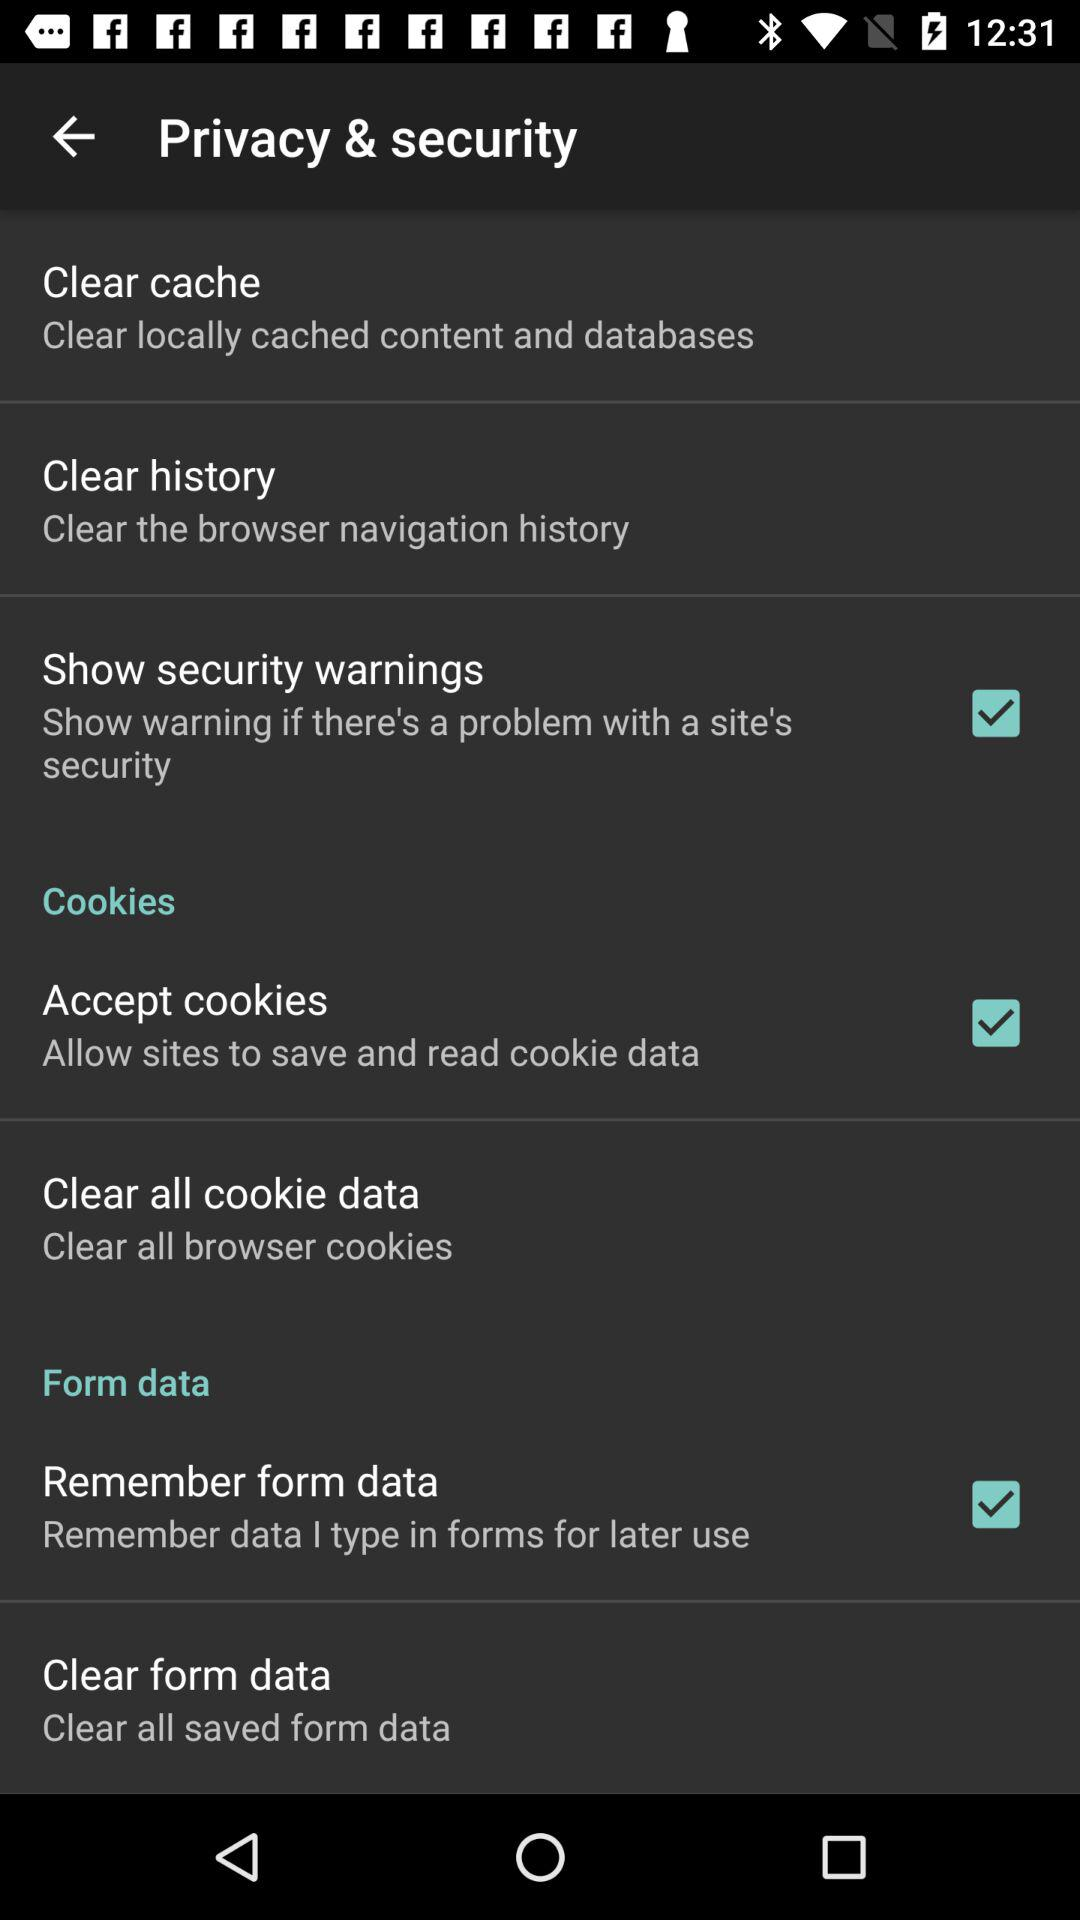What is the description of the "Clear history"? The description is "Clear the browser navigation history". 